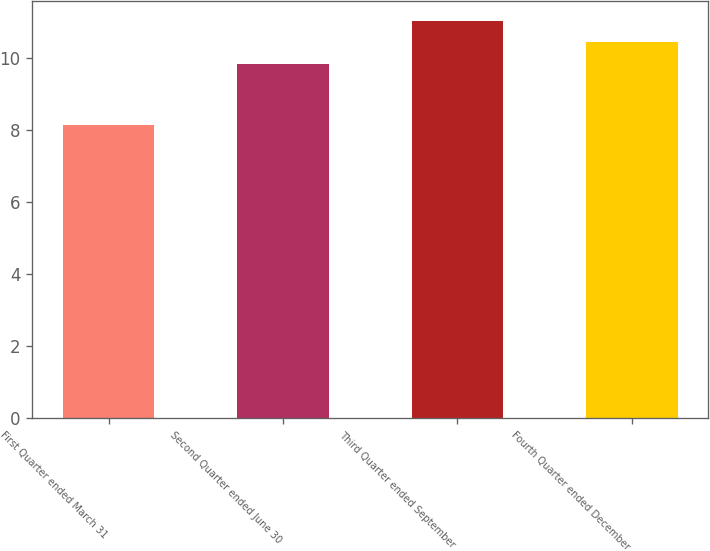Convert chart to OTSL. <chart><loc_0><loc_0><loc_500><loc_500><bar_chart><fcel>First Quarter ended March 31<fcel>Second Quarter ended June 30<fcel>Third Quarter ended September<fcel>Fourth Quarter ended December<nl><fcel>8.14<fcel>9.85<fcel>11.03<fcel>10.44<nl></chart> 